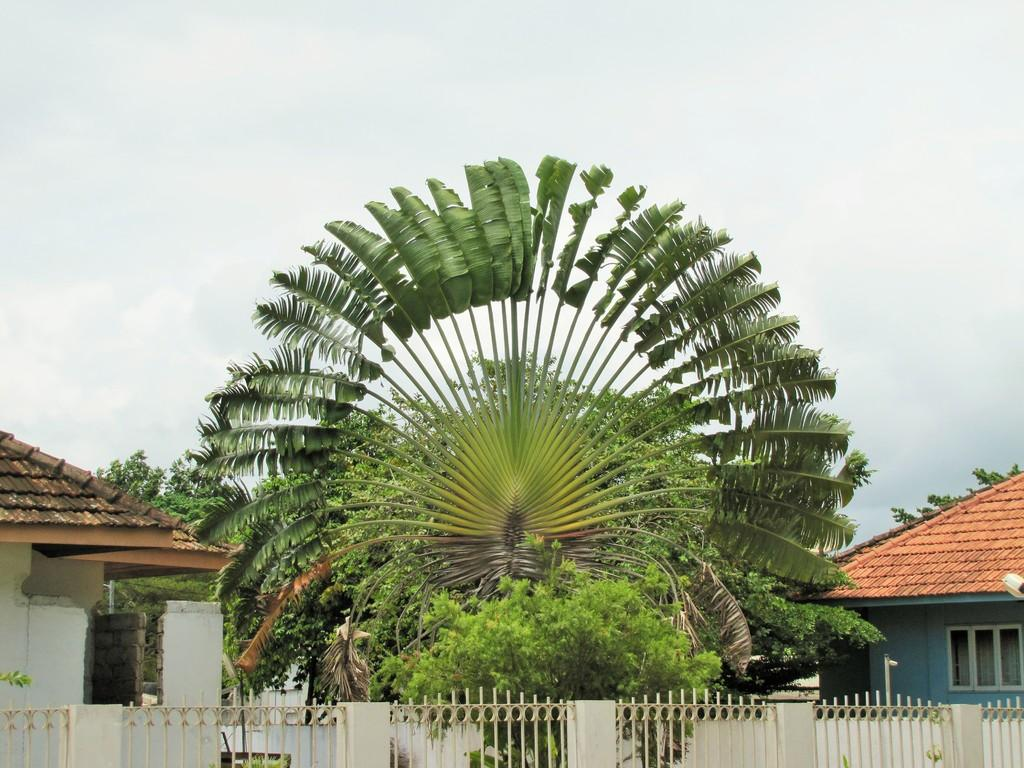What type of structure can be seen in the image? There is railing in the image, which suggests a structure like a balcony or a staircase. What type of buildings are visible in the image? There are houses in the image. What type of illumination is present in the image? There are lights in the image. What type of vertical structure is present in the image? There is a pole in the image. What type of natural vegetation is visible in the image? There are trees in the image. What is visible in the background of the image? The sky is visible in the background of the image. What type of school can be seen in the image? There is no school present in the image. How many police officers are visible in the image? There are no police officers present in the image. 